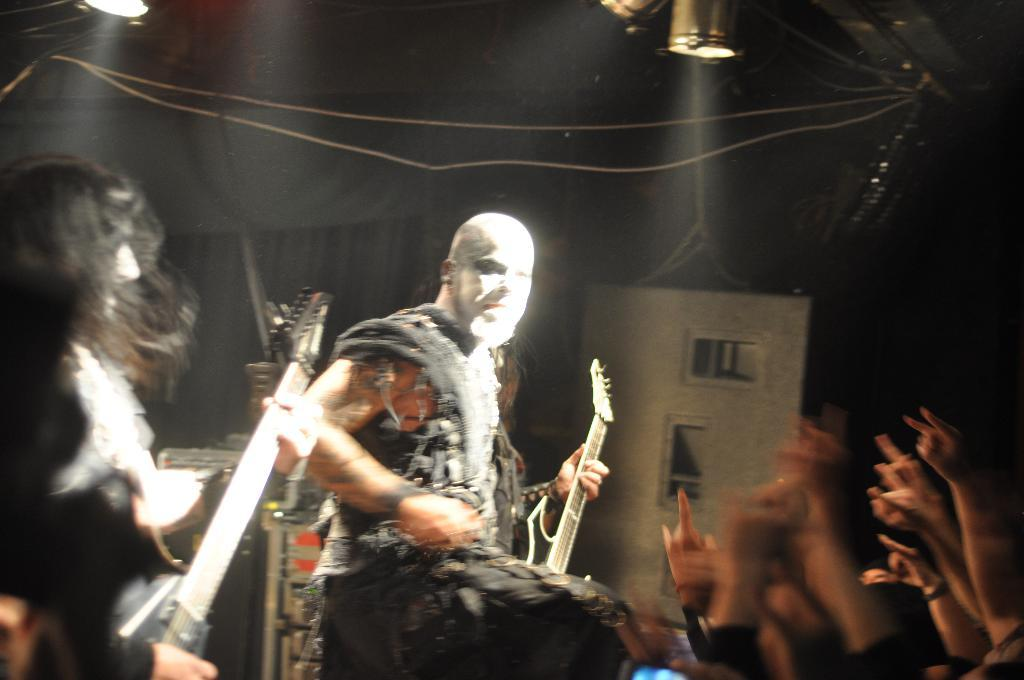How many people are on the stage in the image? There are 3 people on the stage. What are the people on the stage doing? The people on stage are performing by playing musical instruments. Can you describe the audience in the image? There are people in front of the stage, who are likely the audience. What can be seen above the stage in the image? There are lights above the stage. How many breaths can be heard from the pigs in the image? There are no pigs present in the image, so it is not possible to determine the number of breaths. 